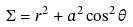<formula> <loc_0><loc_0><loc_500><loc_500>\Sigma = r ^ { 2 } + a ^ { 2 } \cos ^ { 2 } \theta</formula> 